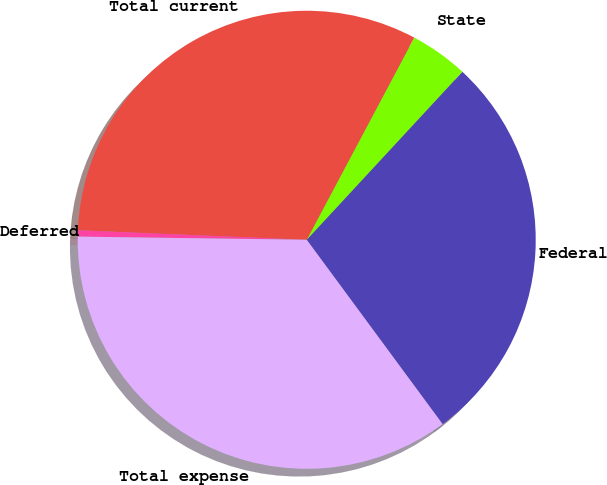<chart> <loc_0><loc_0><loc_500><loc_500><pie_chart><fcel>Federal<fcel>State<fcel>Total current<fcel>Deferred<fcel>Total expense<nl><fcel>28.0%<fcel>4.11%<fcel>32.12%<fcel>0.44%<fcel>35.33%<nl></chart> 